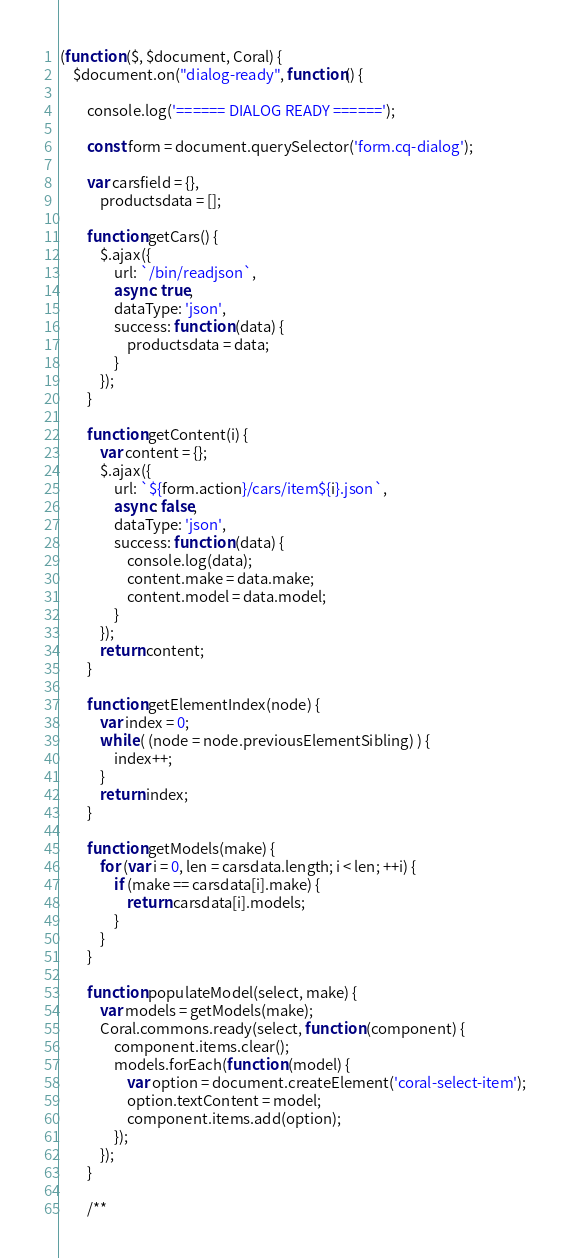<code> <loc_0><loc_0><loc_500><loc_500><_JavaScript_>
(function ($, $document, Coral) {
    $document.on("dialog-ready", function() {

        console.log('====== DIALOG READY ======');

        const form = document.querySelector('form.cq-dialog');

        var carsfield = {},
            productsdata = [];

        function getCars() {
            $.ajax({
                url: `/bin/readjson`,
                async: true,
                dataType: 'json',
                success: function (data) {
                    productsdata = data;
                }
            });
        }

        function getContent(i) {
            var content = {};
            $.ajax({
                url: `${form.action}/cars/item${i}.json`,
                async: false,
                dataType: 'json',
                success: function (data) {
                	console.log(data);
                    content.make = data.make;
                    content.model = data.model;
                }
            });
            return content;
        }

        function getElementIndex(node) {
            var index = 0;
            while ( (node = node.previousElementSibling) ) {
                index++;
            }
            return index;
        }

        function getModels(make) {
            for (var i = 0, len = carsdata.length; i < len; ++i) {
                if (make == carsdata[i].make) {
                    return carsdata[i].models;
                }
            }
        }

        function populateModel(select, make) {
            var models = getModels(make);
            Coral.commons.ready(select, function (component) {
                component.items.clear();
                models.forEach(function (model) {
                    var option = document.createElement('coral-select-item');
                    option.textContent = model;
                    component.items.add(option);
                });
            });
        }

        /**</code> 